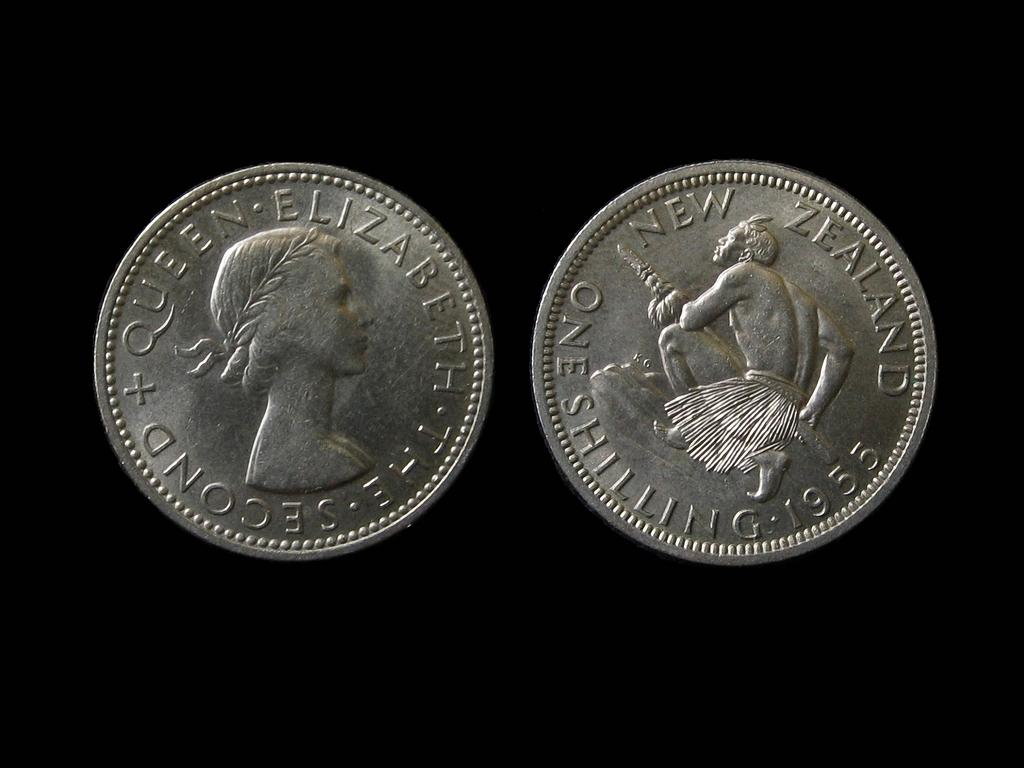<image>
Describe the image concisely. Two silver coins, one of which has the words Queen Elizabeth on it. 